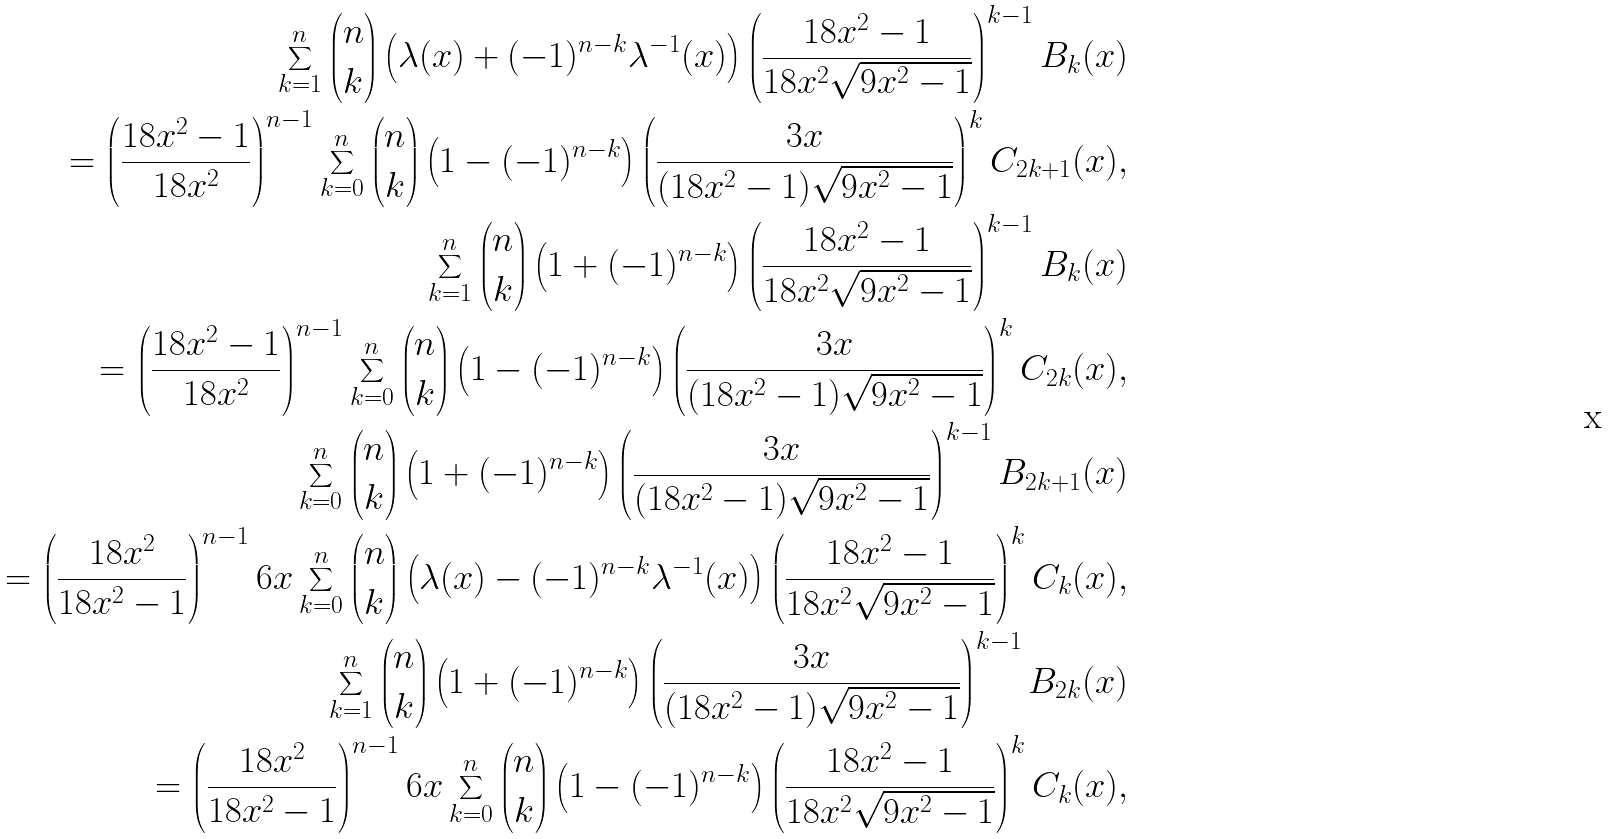Convert formula to latex. <formula><loc_0><loc_0><loc_500><loc_500>\sum _ { k = 1 } ^ { n } { n \choose k } \left ( \lambda ( x ) + ( - 1 ) ^ { n - k } \lambda ^ { - 1 } ( x ) \right ) \left ( \frac { 1 8 x ^ { 2 } - 1 } { 1 8 x ^ { 2 } \sqrt { 9 x ^ { 2 } - 1 } } \right ) ^ { k - 1 } B _ { k } ( x ) \\ = \left ( \frac { 1 8 x ^ { 2 } - 1 } { 1 8 x ^ { 2 } } \right ) ^ { n - 1 } \sum _ { k = 0 } ^ { n } { n \choose k } \left ( 1 - ( - 1 ) ^ { n - k } \right ) \left ( \frac { 3 x } { ( 1 8 x ^ { 2 } - 1 ) \sqrt { 9 x ^ { 2 } - 1 } } \right ) ^ { k } C _ { 2 k + 1 } ( x ) , \\ \sum _ { k = 1 } ^ { n } { n \choose k } \left ( 1 + ( - 1 ) ^ { n - k } \right ) \left ( \frac { 1 8 x ^ { 2 } - 1 } { 1 8 x ^ { 2 } \sqrt { 9 x ^ { 2 } - 1 } } \right ) ^ { k - 1 } B _ { k } ( x ) \\ = \left ( \frac { 1 8 x ^ { 2 } - 1 } { 1 8 x ^ { 2 } } \right ) ^ { n - 1 } \sum _ { k = 0 } ^ { n } { n \choose k } \left ( 1 - ( - 1 ) ^ { n - k } \right ) \left ( \frac { 3 x } { ( 1 8 x ^ { 2 } - 1 ) \sqrt { 9 x ^ { 2 } - 1 } } \right ) ^ { k } C _ { 2 k } ( x ) , \\ \sum _ { k = 0 } ^ { n } { n \choose k } \left ( 1 + ( - 1 ) ^ { n - k } \right ) \left ( \frac { 3 x } { ( 1 8 x ^ { 2 } - 1 ) \sqrt { 9 x ^ { 2 } - 1 } } \right ) ^ { k - 1 } B _ { 2 k + 1 } ( x ) \\ = \left ( \frac { 1 8 x ^ { 2 } } { 1 8 x ^ { 2 } - 1 } \right ) ^ { n - 1 } 6 x \sum _ { k = 0 } ^ { n } { n \choose k } \left ( \lambda ( x ) - ( - 1 ) ^ { n - k } \lambda ^ { - 1 } ( x ) \right ) \left ( \frac { 1 8 x ^ { 2 } - 1 } { 1 8 x ^ { 2 } \sqrt { 9 x ^ { 2 } - 1 } } \right ) ^ { k } C _ { k } ( x ) , \\ \sum _ { k = 1 } ^ { n } { n \choose k } \left ( 1 + ( - 1 ) ^ { n - k } \right ) \left ( \frac { 3 x } { ( 1 8 x ^ { 2 } - 1 ) \sqrt { 9 x ^ { 2 } - 1 } } \right ) ^ { k - 1 } B _ { 2 k } ( x ) \\ = \left ( \frac { 1 8 x ^ { 2 } } { 1 8 x ^ { 2 } - 1 } \right ) ^ { n - 1 } 6 x \sum _ { k = 0 } ^ { n } { n \choose k } \left ( 1 - ( - 1 ) ^ { n - k } \right ) \left ( \frac { 1 8 x ^ { 2 } - 1 } { 1 8 x ^ { 2 } \sqrt { 9 x ^ { 2 } - 1 } } \right ) ^ { k } C _ { k } ( x ) ,</formula> 